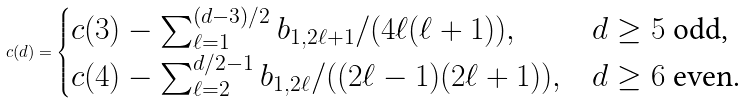Convert formula to latex. <formula><loc_0><loc_0><loc_500><loc_500>c ( d ) = \begin{cases} c ( 3 ) - \sum _ { \ell = 1 } ^ { ( d - 3 ) / 2 } b _ { 1 , 2 \ell + 1 } / ( 4 \ell ( \ell + 1 ) ) , & \text {$d\geq 5$ odd,} \\ c ( 4 ) - \sum _ { \ell = 2 } ^ { d / 2 - 1 } b _ { 1 , 2 \ell } / ( ( 2 \ell - 1 ) ( 2 \ell + 1 ) ) , & \text {$d\geq 6$ even.} \end{cases}</formula> 